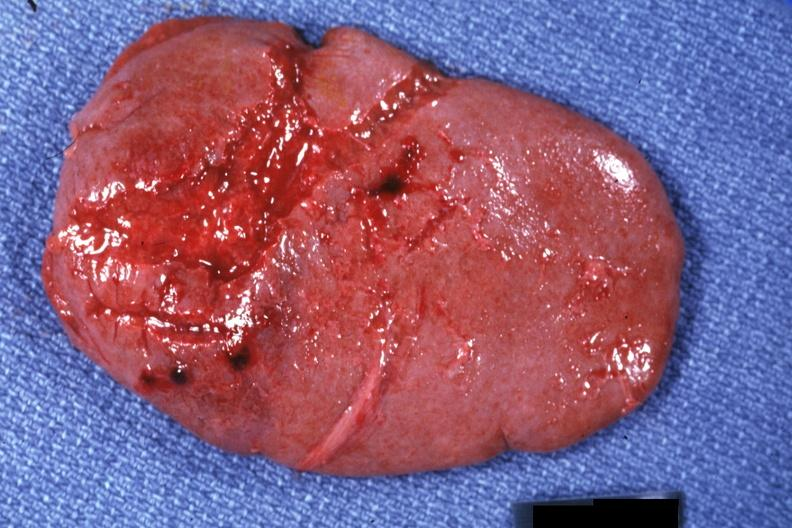what is present?
Answer the question using a single word or phrase. Spleen 